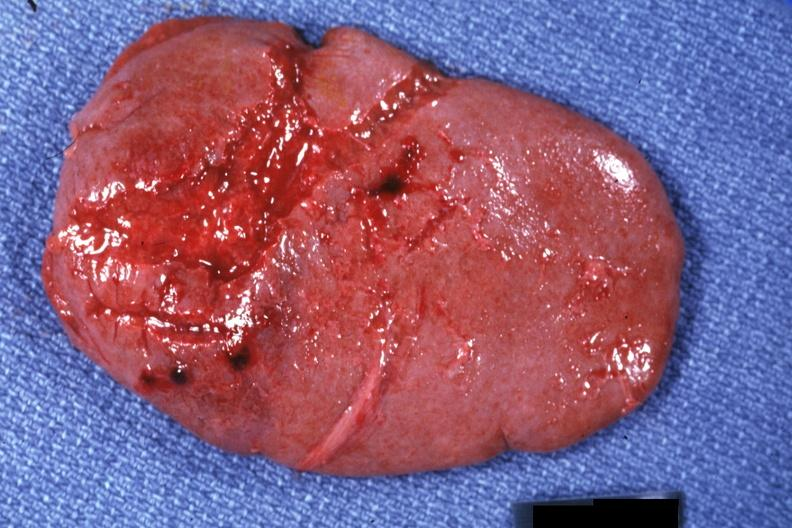what is present?
Answer the question using a single word or phrase. Spleen 